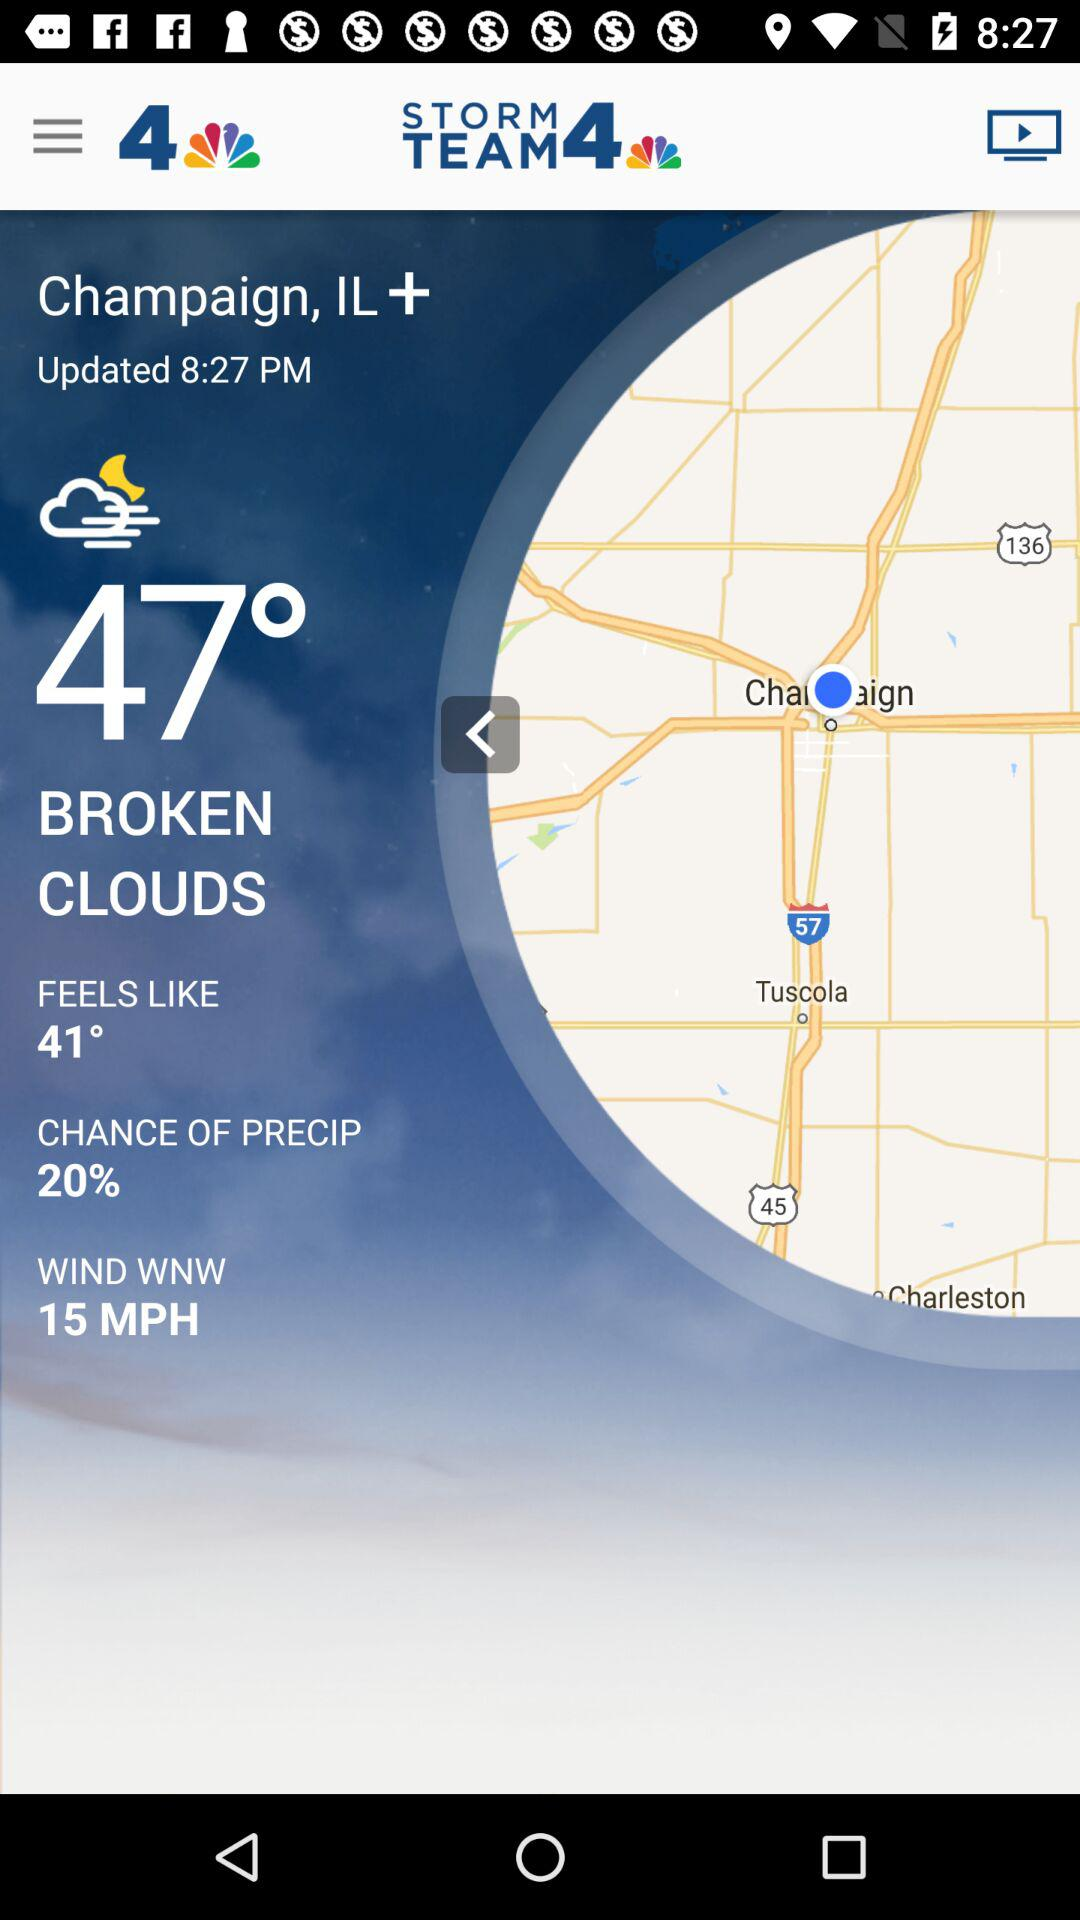What is the percentage chance of precipitation?
Answer the question using a single word or phrase. 20% 